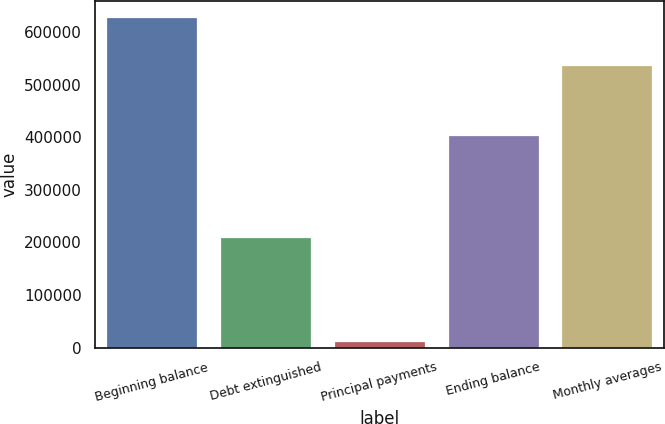<chart> <loc_0><loc_0><loc_500><loc_500><bar_chart><fcel>Beginning balance<fcel>Debt extinguished<fcel>Principal payments<fcel>Ending balance<fcel>Monthly averages<nl><fcel>627689<fcel>210115<fcel>13495<fcel>404079<fcel>536774<nl></chart> 